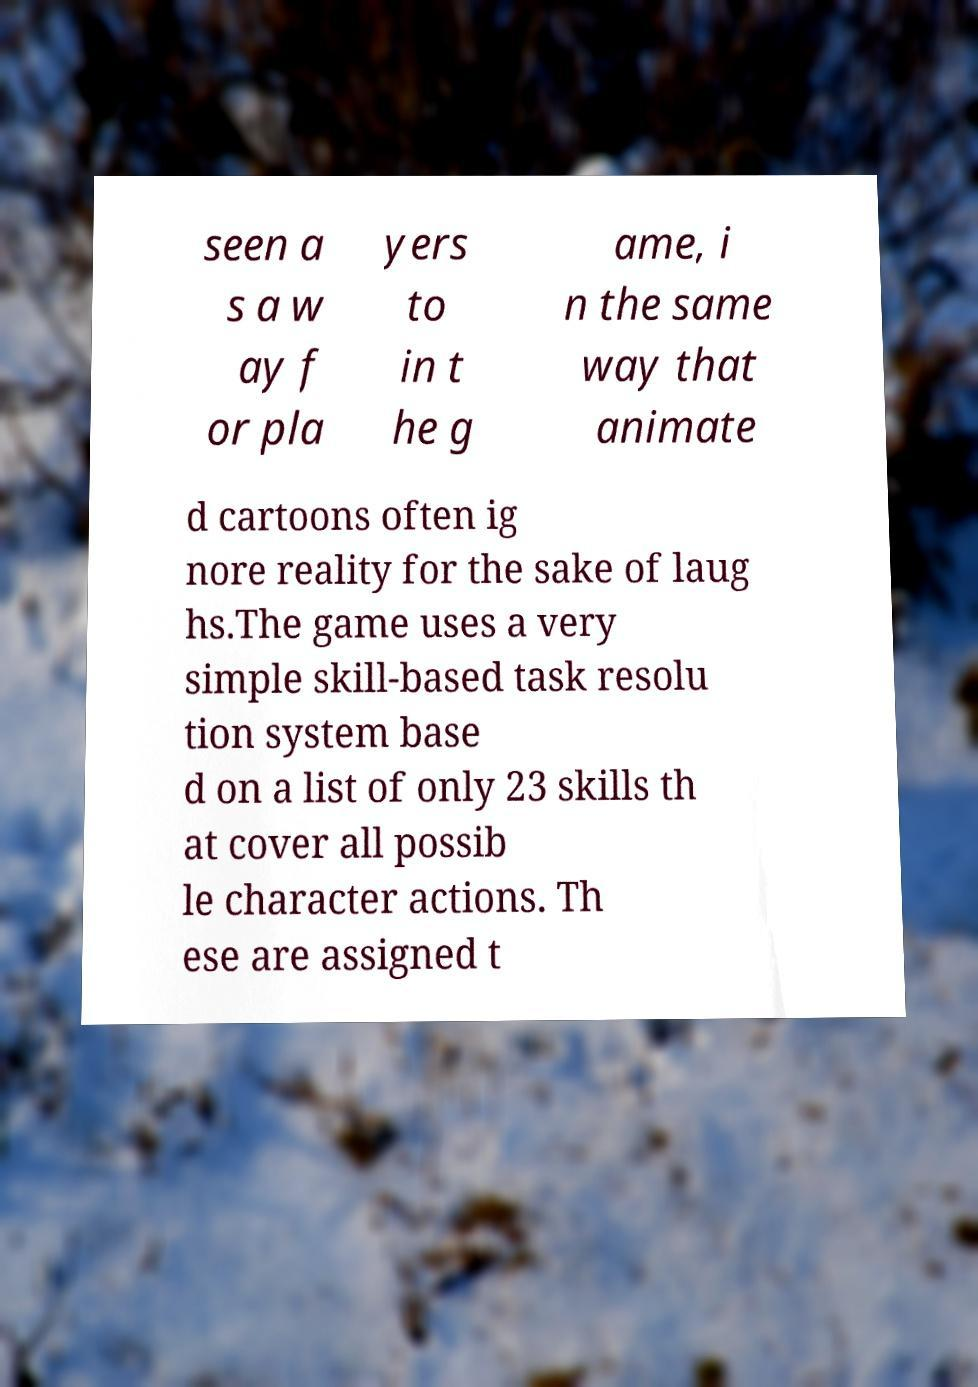Could you assist in decoding the text presented in this image and type it out clearly? seen a s a w ay f or pla yers to in t he g ame, i n the same way that animate d cartoons often ig nore reality for the sake of laug hs.The game uses a very simple skill-based task resolu tion system base d on a list of only 23 skills th at cover all possib le character actions. Th ese are assigned t 